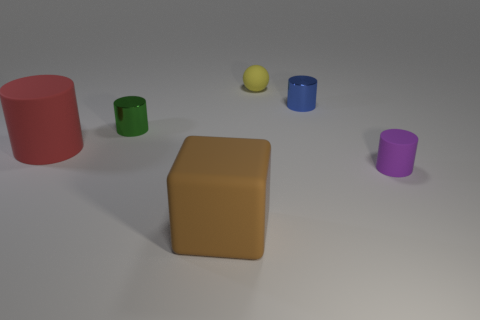There is a cylinder that is both behind the large matte cylinder and on the left side of the brown block; what material is it?
Give a very brief answer. Metal. Does the large red cylinder have the same material as the tiny green cylinder that is on the left side of the rubber block?
Provide a succinct answer. No. Is there any other thing that is the same size as the red matte cylinder?
Your response must be concise. Yes. How many objects are either gray matte balls or metallic cylinders on the right side of the large brown thing?
Make the answer very short. 1. Is the size of the matte thing that is right of the blue metal cylinder the same as the rubber cylinder that is left of the rubber sphere?
Provide a succinct answer. No. There is a red cylinder; does it have the same size as the thing that is behind the small blue shiny thing?
Ensure brevity in your answer.  No. What is the size of the purple matte cylinder right of the rubber thing that is to the left of the large brown matte block?
Your answer should be very brief. Small. What color is the other shiny object that is the same shape as the tiny green shiny thing?
Make the answer very short. Blue. Do the brown matte object and the yellow ball have the same size?
Ensure brevity in your answer.  No. Is the number of green shiny things in front of the red cylinder the same as the number of yellow matte balls?
Your answer should be very brief. No. 